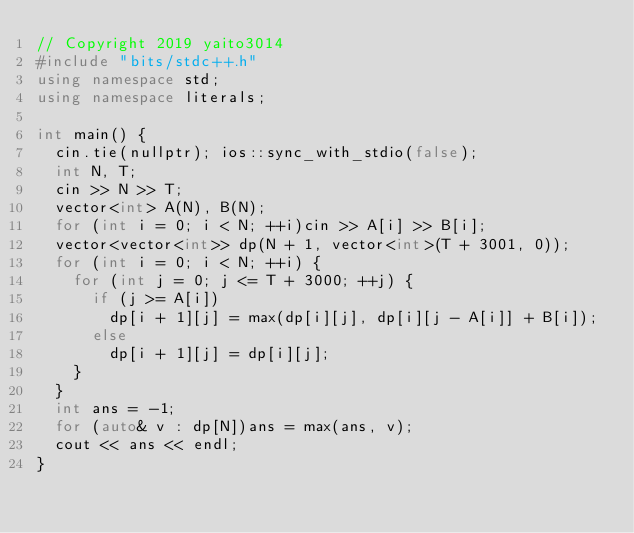Convert code to text. <code><loc_0><loc_0><loc_500><loc_500><_C++_>// Copyright 2019 yaito3014
#include "bits/stdc++.h"
using namespace std;
using namespace literals;

int main() {
  cin.tie(nullptr); ios::sync_with_stdio(false);
  int N, T;
  cin >> N >> T;
  vector<int> A(N), B(N);
  for (int i = 0; i < N; ++i)cin >> A[i] >> B[i];
  vector<vector<int>> dp(N + 1, vector<int>(T + 3001, 0));
  for (int i = 0; i < N; ++i) {
    for (int j = 0; j <= T + 3000; ++j) {
      if (j >= A[i])
        dp[i + 1][j] = max(dp[i][j], dp[i][j - A[i]] + B[i]);
      else
        dp[i + 1][j] = dp[i][j];
    }
  }
  int ans = -1;
  for (auto& v : dp[N])ans = max(ans, v);
  cout << ans << endl;
}
</code> 